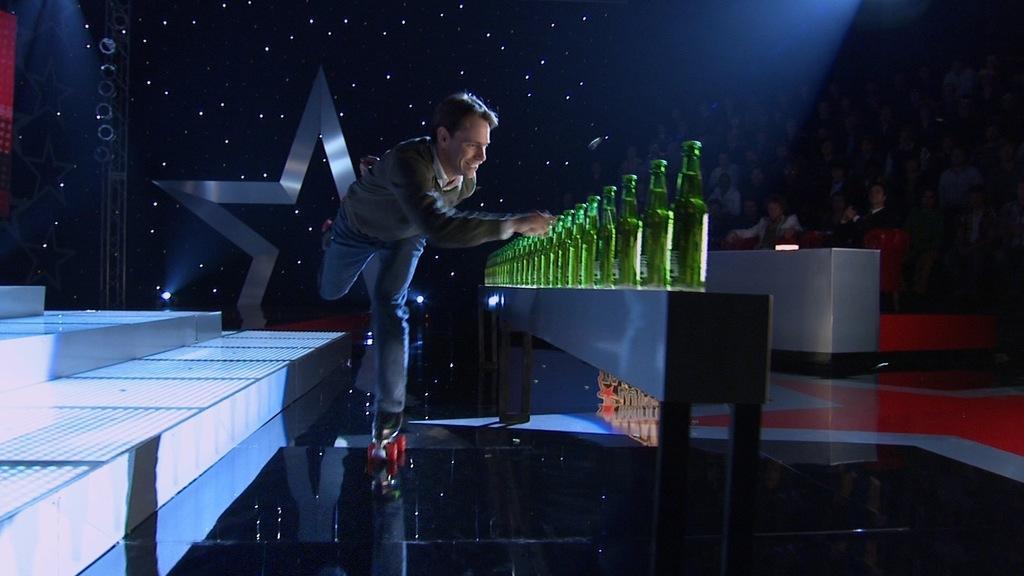In one or two sentences, can you explain what this image depicts? A man is opening series of bottles while roller skating. 